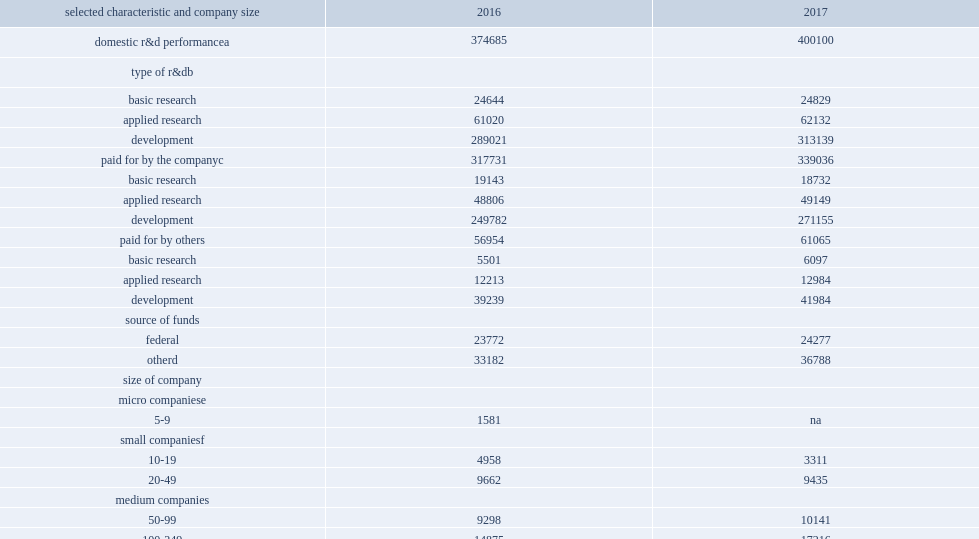How many million dollars did businesses spend on research and development performance in the united states in 2017? 400100.0. Businesses spent $400 billion on research and development performance in the united states in 2017, how many percent of increase from 2016? 0.06783. How many million dollars was funding from the companies' own sources in 2017? 339036.0. Funding from the companies' own sources was $339 billion in 2017, how many percent of increase from 2016? 0.067054. How many million dollars was funding from other sources in 2017? 61065.0. How many million dollars was funding from other sources in 2016? 56954.0. In 2017, of the $400 million companies spent on r&d, how many million dollars were spent on basic research? 24829.0. In 2017, of the $400 million companies spent on r&d, how many million dollars were spent on applied research? 62132.0. In 2017, of the $400 million companies spent on r&d, how many million dollars were spent on development? 313139.0. 